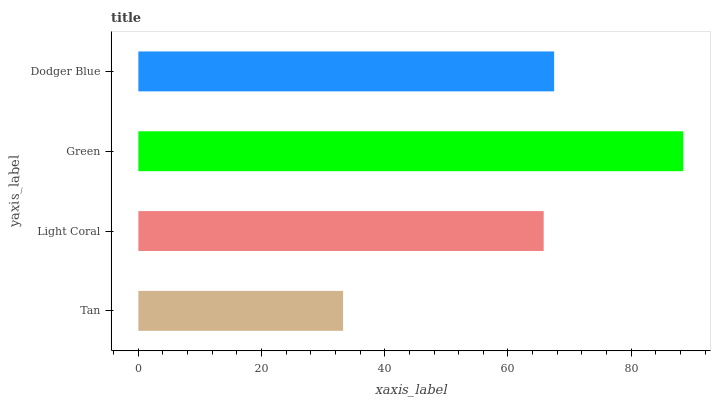Is Tan the minimum?
Answer yes or no. Yes. Is Green the maximum?
Answer yes or no. Yes. Is Light Coral the minimum?
Answer yes or no. No. Is Light Coral the maximum?
Answer yes or no. No. Is Light Coral greater than Tan?
Answer yes or no. Yes. Is Tan less than Light Coral?
Answer yes or no. Yes. Is Tan greater than Light Coral?
Answer yes or no. No. Is Light Coral less than Tan?
Answer yes or no. No. Is Dodger Blue the high median?
Answer yes or no. Yes. Is Light Coral the low median?
Answer yes or no. Yes. Is Green the high median?
Answer yes or no. No. Is Green the low median?
Answer yes or no. No. 